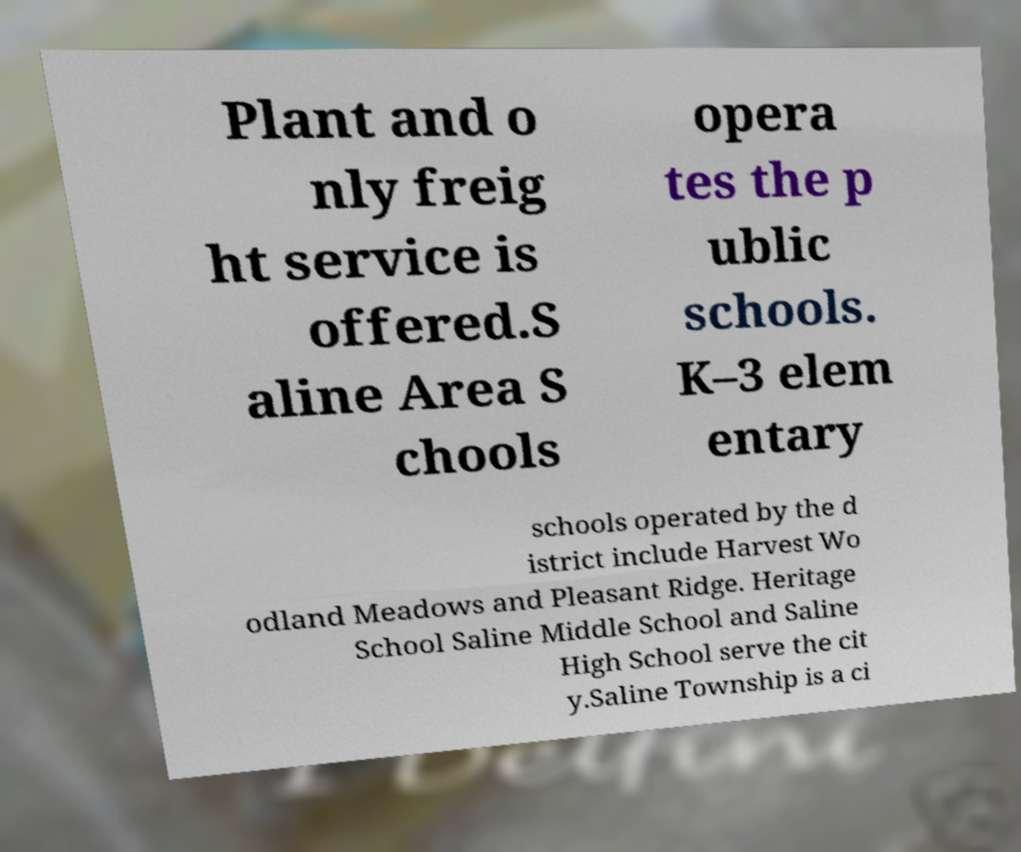Please identify and transcribe the text found in this image. Plant and o nly freig ht service is offered.S aline Area S chools opera tes the p ublic schools. K–3 elem entary schools operated by the d istrict include Harvest Wo odland Meadows and Pleasant Ridge. Heritage School Saline Middle School and Saline High School serve the cit y.Saline Township is a ci 